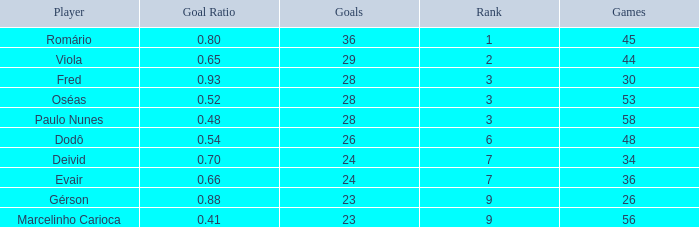How many goal ratios have rank of 2 with more than 44 games? 0.0. 